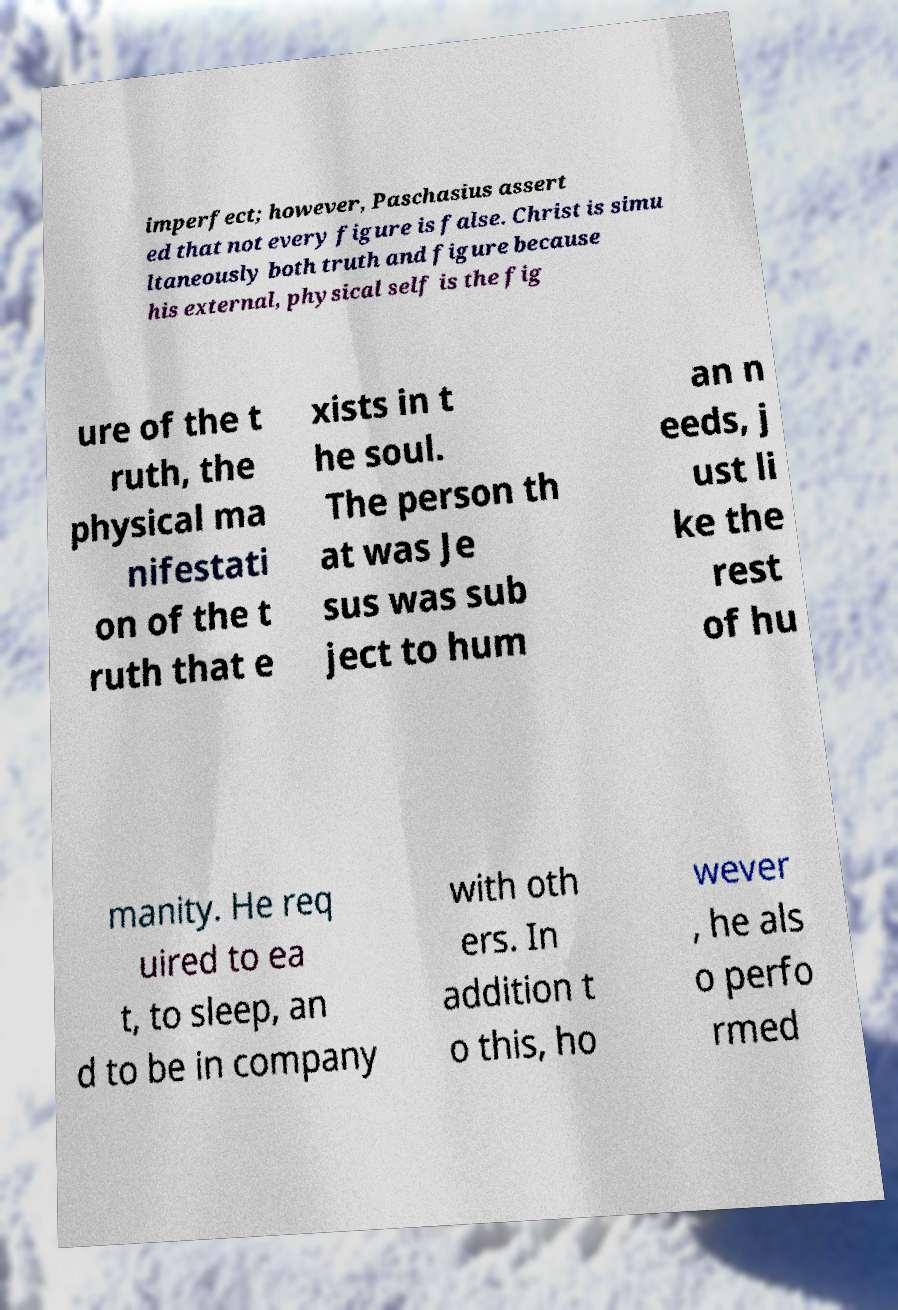There's text embedded in this image that I need extracted. Can you transcribe it verbatim? imperfect; however, Paschasius assert ed that not every figure is false. Christ is simu ltaneously both truth and figure because his external, physical self is the fig ure of the t ruth, the physical ma nifestati on of the t ruth that e xists in t he soul. The person th at was Je sus was sub ject to hum an n eeds, j ust li ke the rest of hu manity. He req uired to ea t, to sleep, an d to be in company with oth ers. In addition t o this, ho wever , he als o perfo rmed 